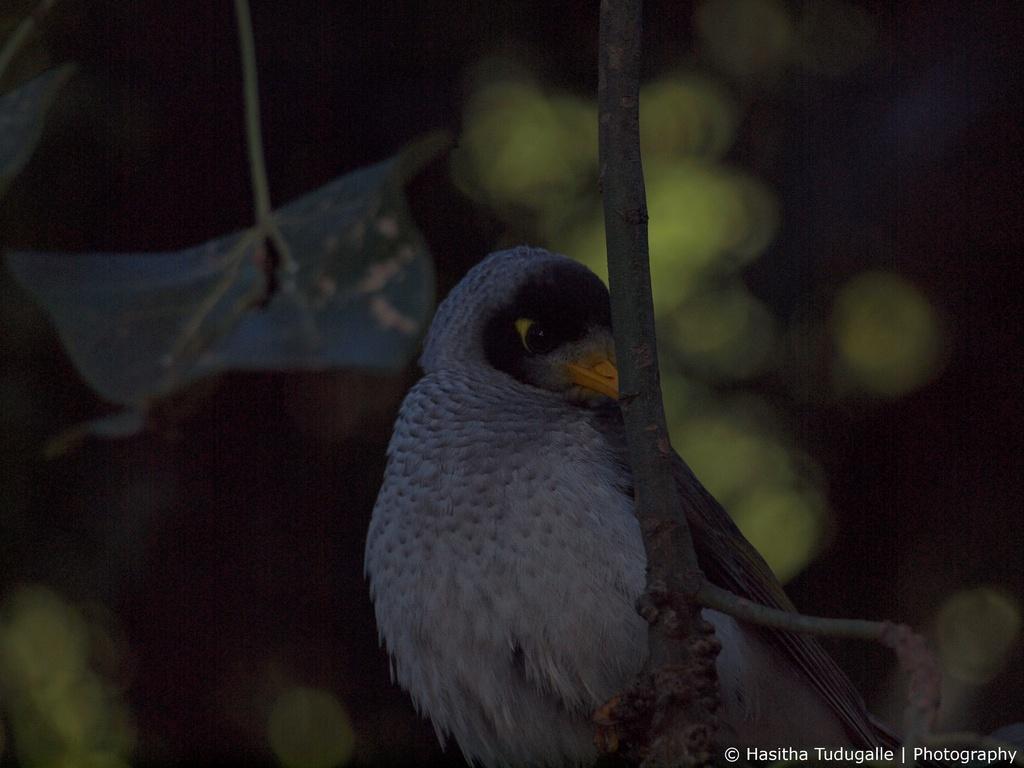Could you give a brief overview of what you see in this image? This image consists of a branch. On that there is a bird. It is in ash color. There are leaves behind that. 